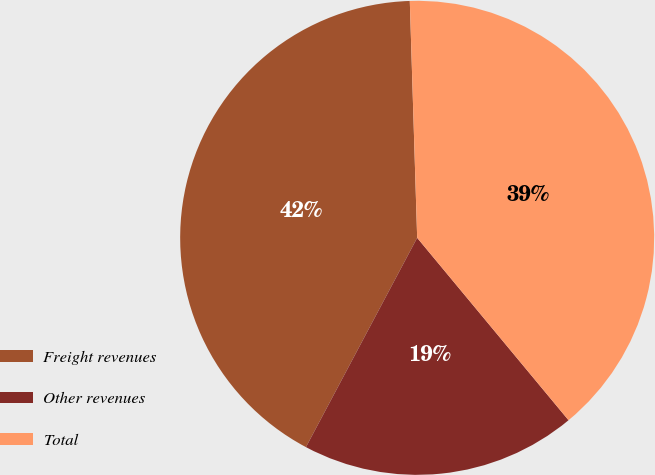Convert chart to OTSL. <chart><loc_0><loc_0><loc_500><loc_500><pie_chart><fcel>Freight revenues<fcel>Other revenues<fcel>Total<nl><fcel>41.73%<fcel>18.8%<fcel>39.47%<nl></chart> 